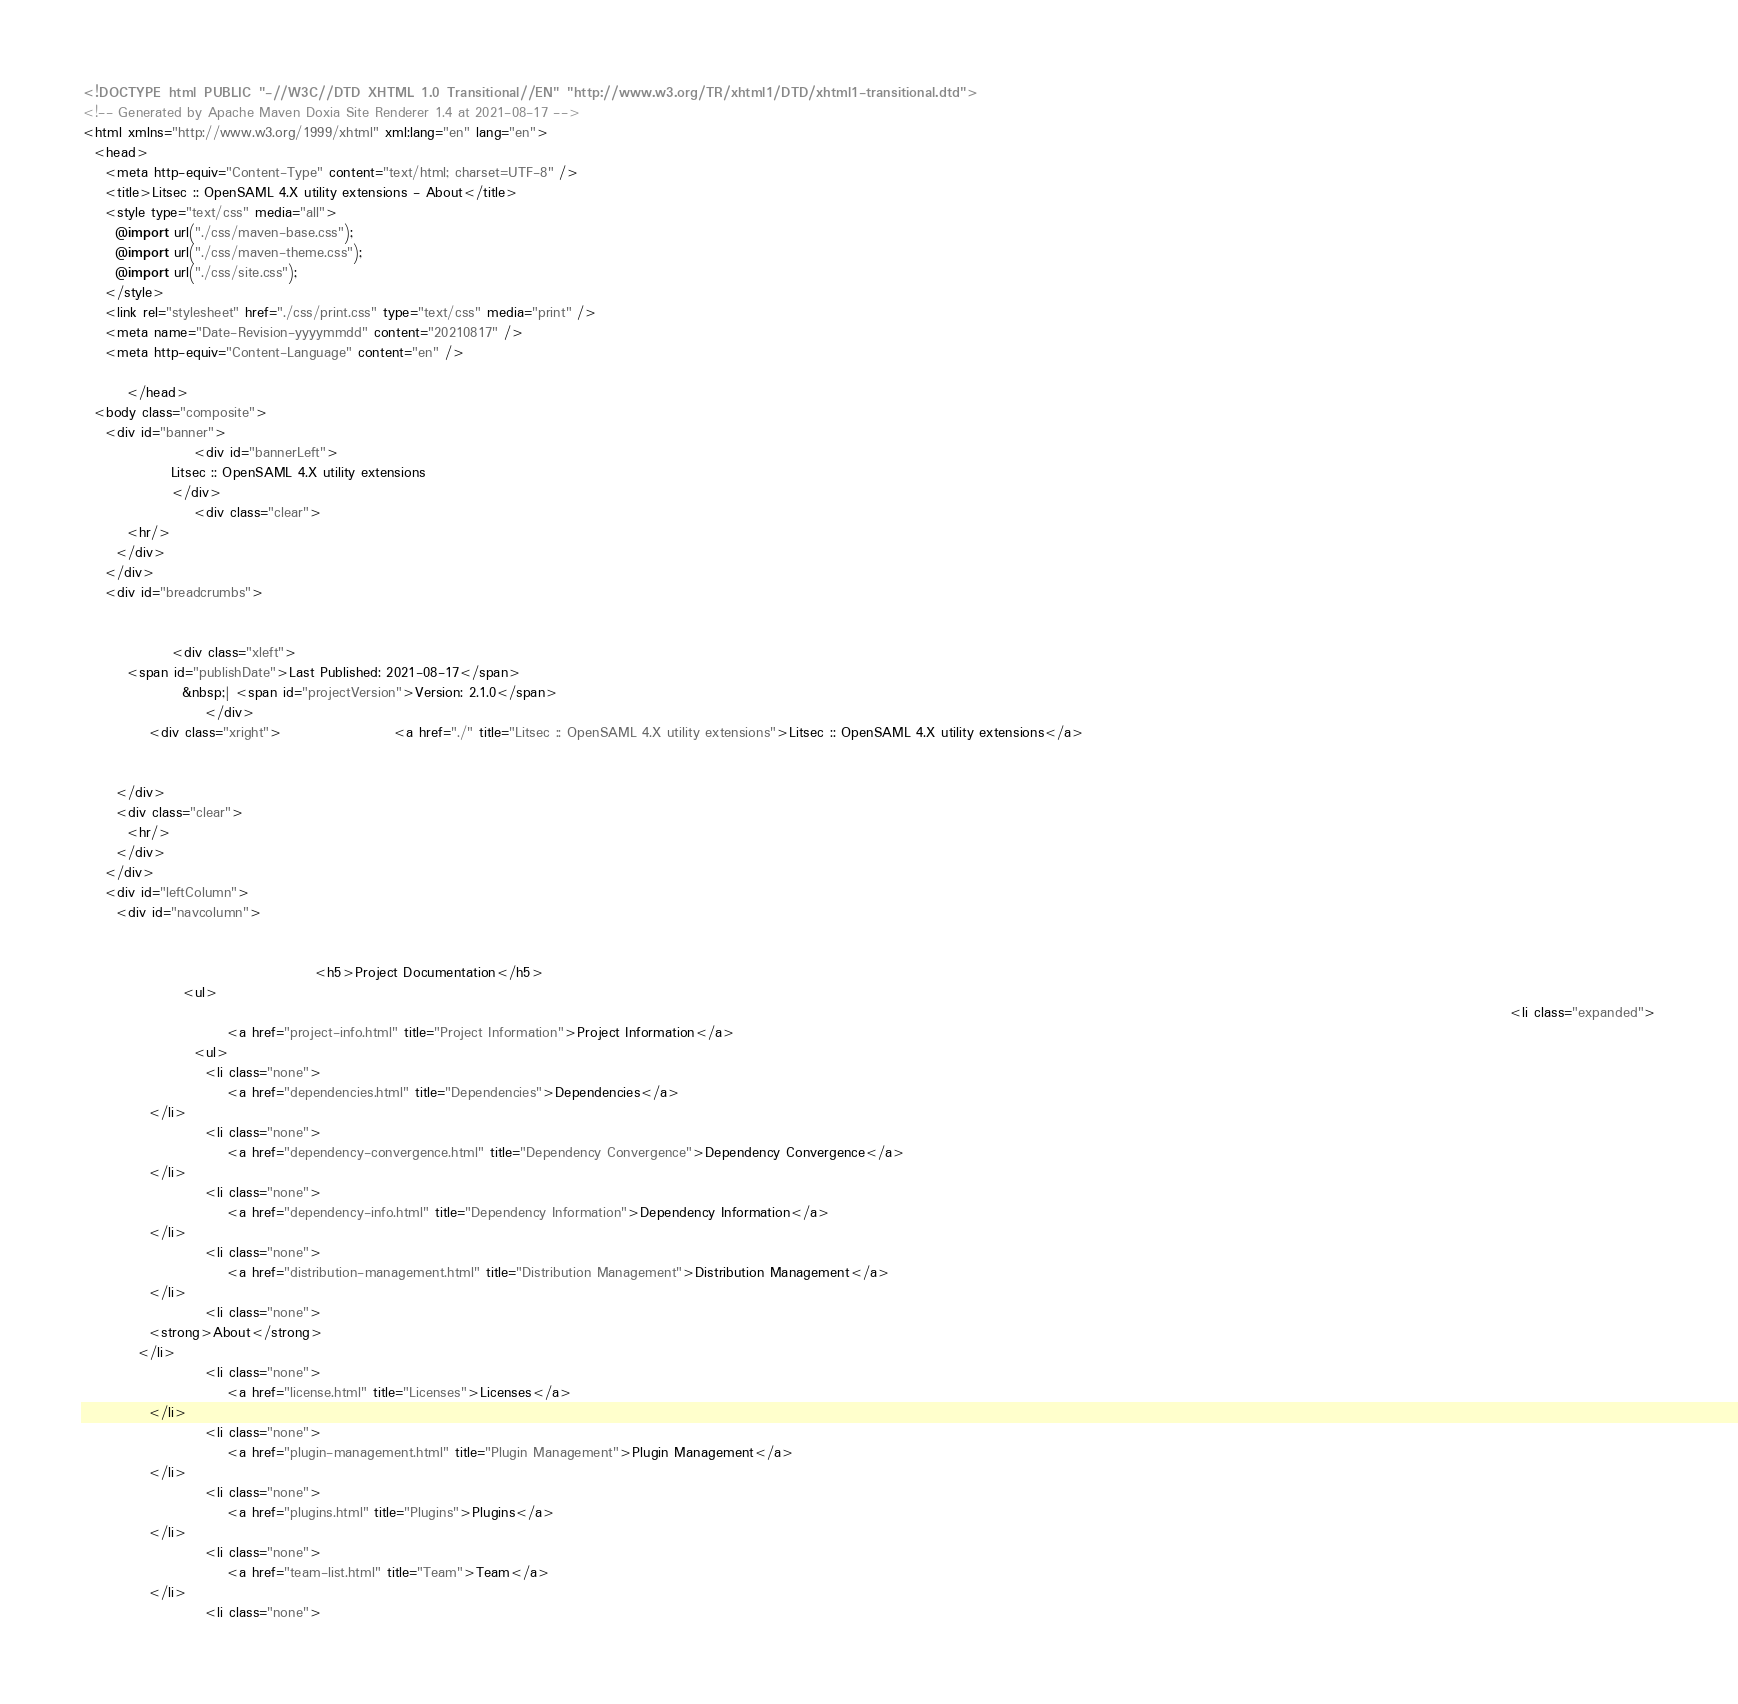Convert code to text. <code><loc_0><loc_0><loc_500><loc_500><_HTML_><!DOCTYPE html PUBLIC "-//W3C//DTD XHTML 1.0 Transitional//EN" "http://www.w3.org/TR/xhtml1/DTD/xhtml1-transitional.dtd">
<!-- Generated by Apache Maven Doxia Site Renderer 1.4 at 2021-08-17 -->
<html xmlns="http://www.w3.org/1999/xhtml" xml:lang="en" lang="en">
  <head>
    <meta http-equiv="Content-Type" content="text/html; charset=UTF-8" />
    <title>Litsec :: OpenSAML 4.X utility extensions - About</title>
    <style type="text/css" media="all">
      @import url("./css/maven-base.css");
      @import url("./css/maven-theme.css");
      @import url("./css/site.css");
    </style>
    <link rel="stylesheet" href="./css/print.css" type="text/css" media="print" />
    <meta name="Date-Revision-yyyymmdd" content="20210817" />
    <meta http-equiv="Content-Language" content="en" />
        
        </head>
  <body class="composite">
    <div id="banner">
                    <div id="bannerLeft">
                Litsec :: OpenSAML 4.X utility extensions
                </div>
                    <div class="clear">
        <hr/>
      </div>
    </div>
    <div id="breadcrumbs">
            
                    
                <div class="xleft">
        <span id="publishDate">Last Published: 2021-08-17</span>
                  &nbsp;| <span id="projectVersion">Version: 2.1.0</span>
                      </div>
            <div class="xright">                    <a href="./" title="Litsec :: OpenSAML 4.X utility extensions">Litsec :: OpenSAML 4.X utility extensions</a>
              
                    
      </div>
      <div class="clear">
        <hr/>
      </div>
    </div>
    <div id="leftColumn">
      <div id="navcolumn">
             
                    
                                          <h5>Project Documentation</h5>
                  <ul>
                                                                                                                                                                                                                                                                  <li class="expanded">
                          <a href="project-info.html" title="Project Information">Project Information</a>
                    <ul>
                      <li class="none">
                          <a href="dependencies.html" title="Dependencies">Dependencies</a>
            </li>
                      <li class="none">
                          <a href="dependency-convergence.html" title="Dependency Convergence">Dependency Convergence</a>
            </li>
                      <li class="none">
                          <a href="dependency-info.html" title="Dependency Information">Dependency Information</a>
            </li>
                      <li class="none">
                          <a href="distribution-management.html" title="Distribution Management">Distribution Management</a>
            </li>
                      <li class="none">
            <strong>About</strong>
          </li>
                      <li class="none">
                          <a href="license.html" title="Licenses">Licenses</a>
            </li>
                      <li class="none">
                          <a href="plugin-management.html" title="Plugin Management">Plugin Management</a>
            </li>
                      <li class="none">
                          <a href="plugins.html" title="Plugins">Plugins</a>
            </li>
                      <li class="none">
                          <a href="team-list.html" title="Team">Team</a>
            </li>
                      <li class="none"></code> 